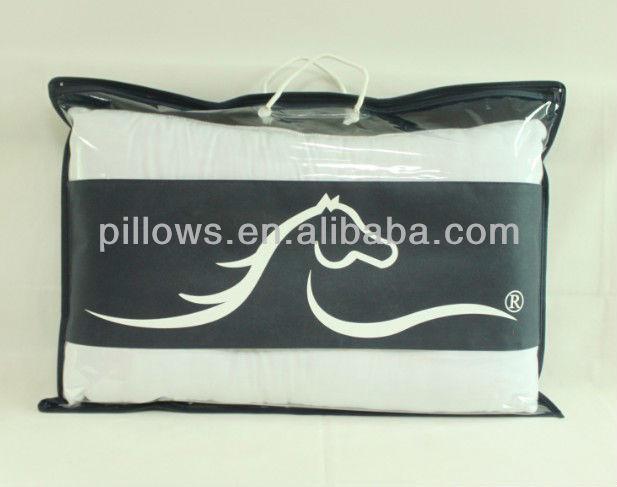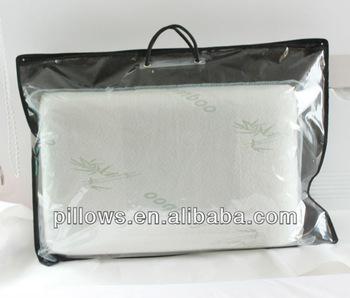The first image is the image on the left, the second image is the image on the right. Given the left and right images, does the statement "An image shows a pillow in a transparent bag with a black handle and black edges." hold true? Answer yes or no. Yes. 